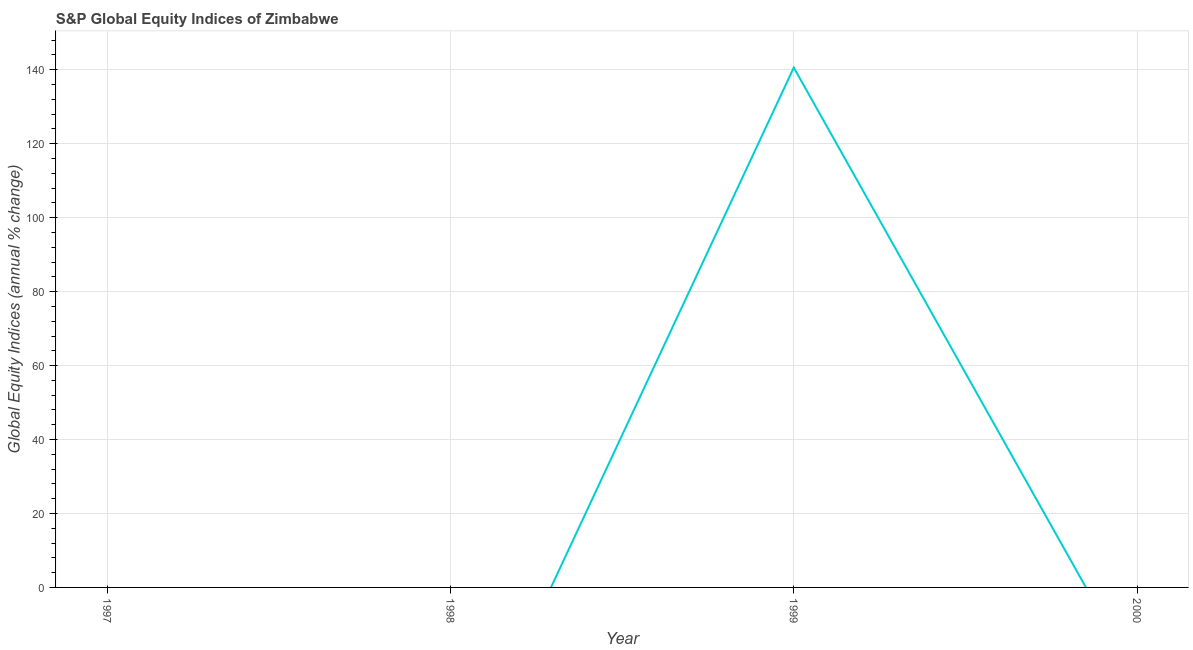Across all years, what is the maximum s&p global equity indices?
Offer a very short reply. 140.6. Across all years, what is the minimum s&p global equity indices?
Ensure brevity in your answer.  0. In which year was the s&p global equity indices maximum?
Offer a terse response. 1999. What is the sum of the s&p global equity indices?
Provide a succinct answer. 140.6. What is the average s&p global equity indices per year?
Provide a short and direct response. 35.15. What is the median s&p global equity indices?
Make the answer very short. 0. What is the difference between the highest and the lowest s&p global equity indices?
Your answer should be compact. 140.6. In how many years, is the s&p global equity indices greater than the average s&p global equity indices taken over all years?
Ensure brevity in your answer.  1. Does the s&p global equity indices monotonically increase over the years?
Offer a terse response. No. Are the values on the major ticks of Y-axis written in scientific E-notation?
Your answer should be compact. No. Does the graph contain any zero values?
Offer a very short reply. Yes. Does the graph contain grids?
Offer a very short reply. Yes. What is the title of the graph?
Make the answer very short. S&P Global Equity Indices of Zimbabwe. What is the label or title of the X-axis?
Provide a succinct answer. Year. What is the label or title of the Y-axis?
Keep it short and to the point. Global Equity Indices (annual % change). What is the Global Equity Indices (annual % change) in 1999?
Offer a terse response. 140.6. What is the Global Equity Indices (annual % change) in 2000?
Your response must be concise. 0. 